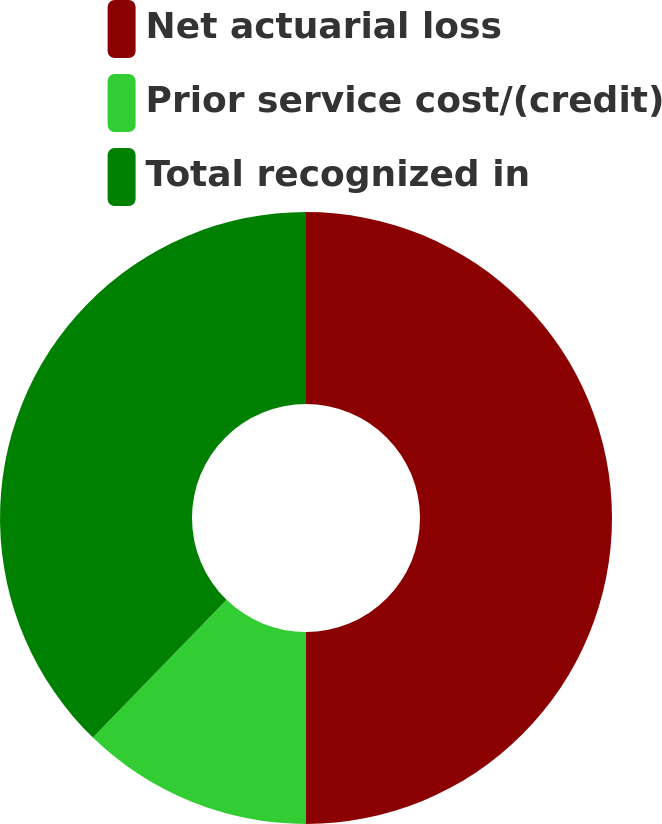Convert chart to OTSL. <chart><loc_0><loc_0><loc_500><loc_500><pie_chart><fcel>Net actuarial loss<fcel>Prior service cost/(credit)<fcel>Total recognized in<nl><fcel>50.0%<fcel>12.26%<fcel>37.74%<nl></chart> 